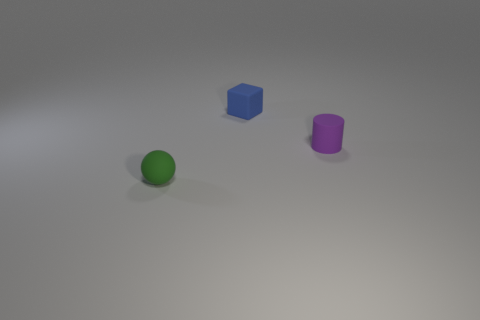Add 1 green objects. How many objects exist? 4 Subtract all blocks. How many objects are left? 2 Add 2 small matte cylinders. How many small matte cylinders exist? 3 Subtract 0 cyan cylinders. How many objects are left? 3 Subtract all cylinders. Subtract all rubber cylinders. How many objects are left? 1 Add 2 blue blocks. How many blue blocks are left? 3 